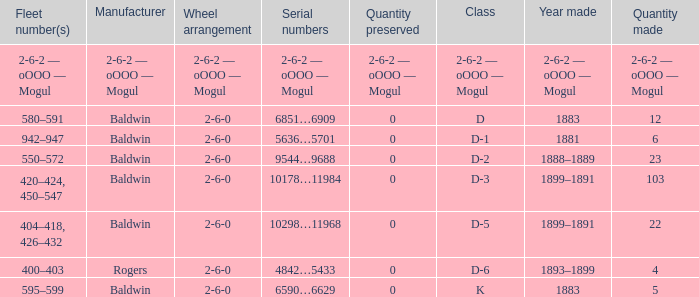What is the wheel arrangement when the year made is 1881? 2-6-0. 